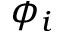<formula> <loc_0><loc_0><loc_500><loc_500>\phi _ { i }</formula> 